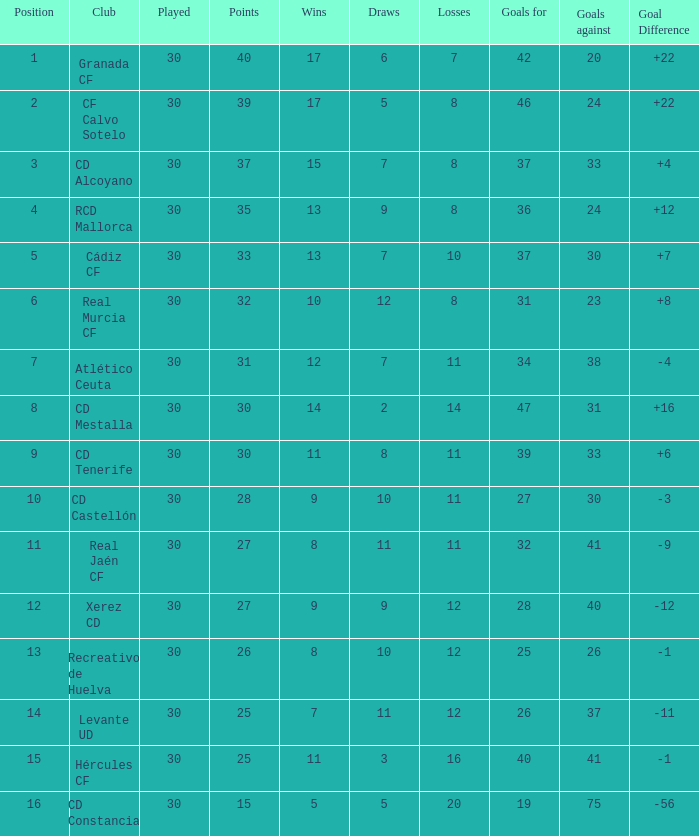Which Wins have a Goal Difference larger than 12, and a Club of granada cf, and Played larger than 30? None. 